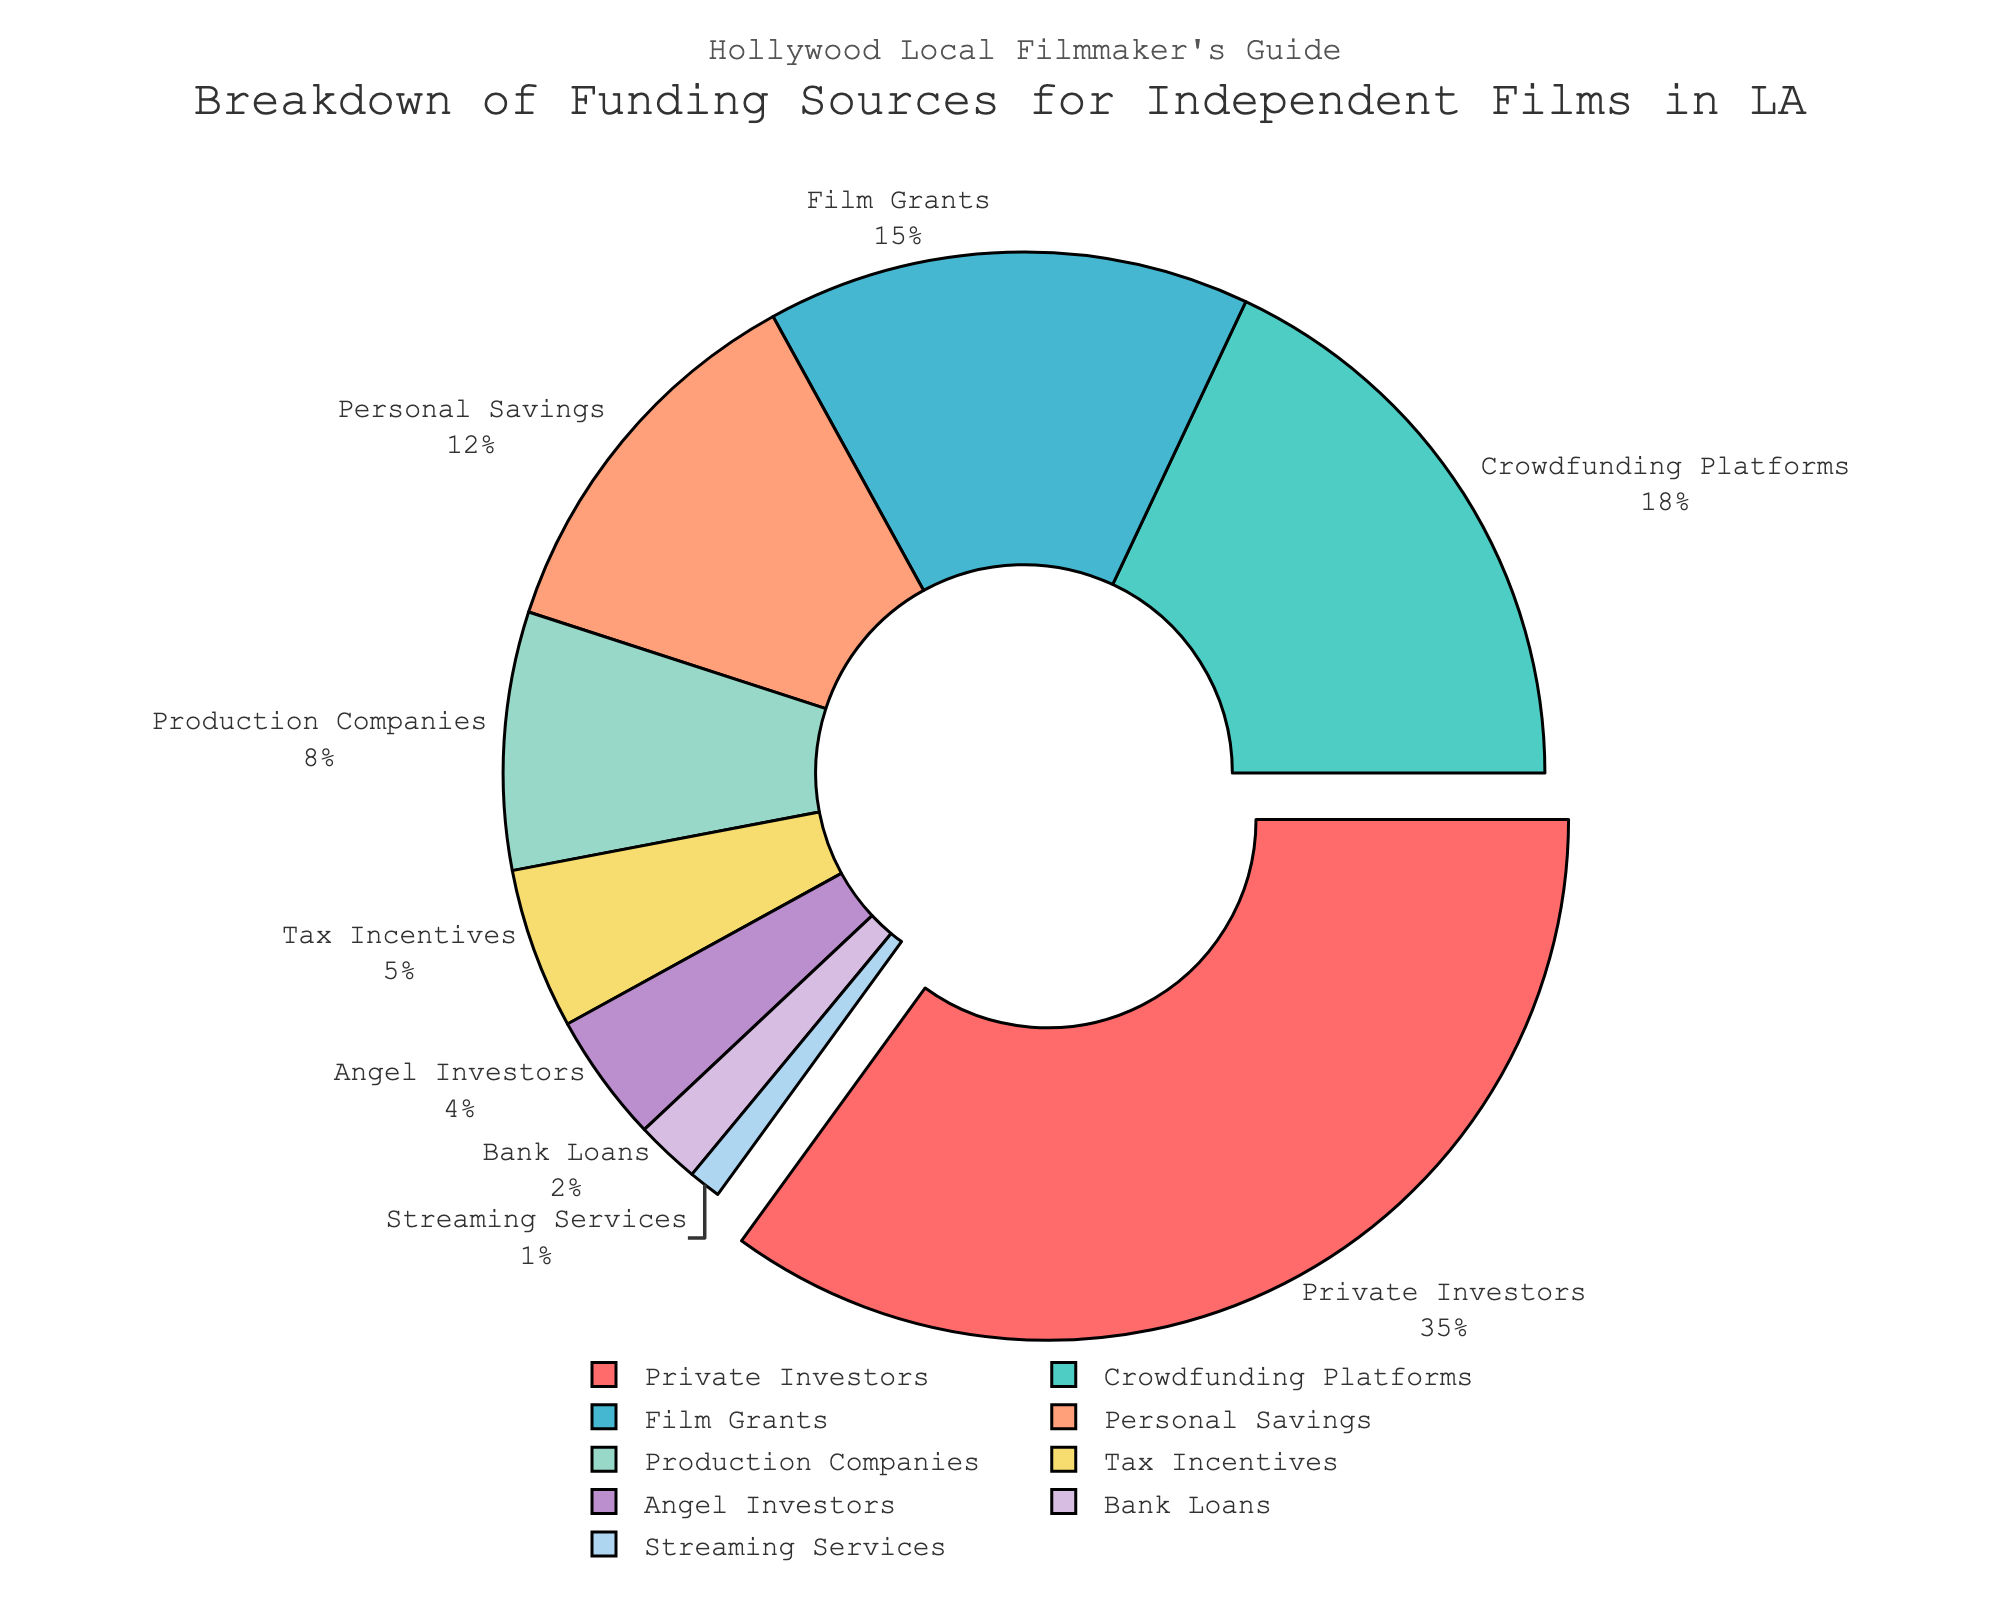Which funding source has the highest percentage? The segment with the largest percentage will be highlighted due to the pull effect, and represents Private Investors at 35%.
Answer: Private Investors What is the least common funding source for independent films in LA? The smallest segment on the pie chart corresponds to Streaming Services, which has only 1%.
Answer: Streaming Services What's the total percentage of funding that comes from Crowdfunding Platforms and Film Grants combined? Add the percentages of Crowdfunding Platforms (18%) and Film Grants (15%) to get the combined total. 18 + 15 = 33%
Answer: 33% How does the percentage from Tax Incentives compare to Personal Savings? Look at the pie chart segments for Tax Incentives (5%) and Personal Savings (12%). Tax Incentives contribute less than Personal Savings.
Answer: Less Which funding source has a percentage that is exactly double another funding source? The pie chart shows that Crowdfunding Platforms have 18% and Film Grants have 15%. Crowdfunding Platforms' 18% is double Production Companies' 8%.
Answer: Production Companies What is the difference in funding percentage between Private Investors and Angel Investors? Subtract the percentage of Angel Investors (4%) from Private Investors (35%). 35 - 4 = 31%
Answer: 31% How many sources contribute equal to or less than 5%? Identify the segments on the pie chart with percentages equal to or less than 5%: Tax Incentives (5%), Angel Investors (4%), Bank Loans (2%), and Streaming Services (1%). Count these sources: 4 in total.
Answer: 4 What is the combined percentage of funding from all sources that contribute less than 10% each? Add the percentages of all sources contributing less than 10%: Production Companies (8%), Tax Incentives (5%), Angel Investors (4%), Bank Loans (2%), and Streaming Services (1%). 8 + 5 + 4 + 2 + 1 = 20%
Answer: 20% If you removed the funding from Private Investors, what would be the new total percentage from the remaining sources? Subtract Private Investors' percentage (35%) from the total 100%. 100 - 35 = 65%
Answer: 65% 